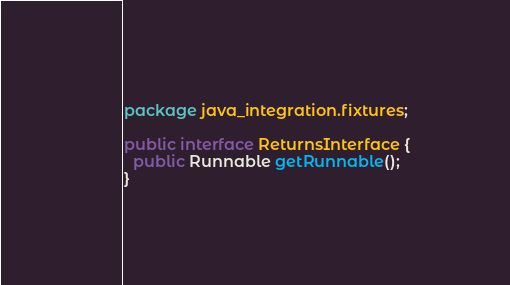Convert code to text. <code><loc_0><loc_0><loc_500><loc_500><_Java_>package java_integration.fixtures;

public interface ReturnsInterface {
  public Runnable getRunnable();
}</code> 